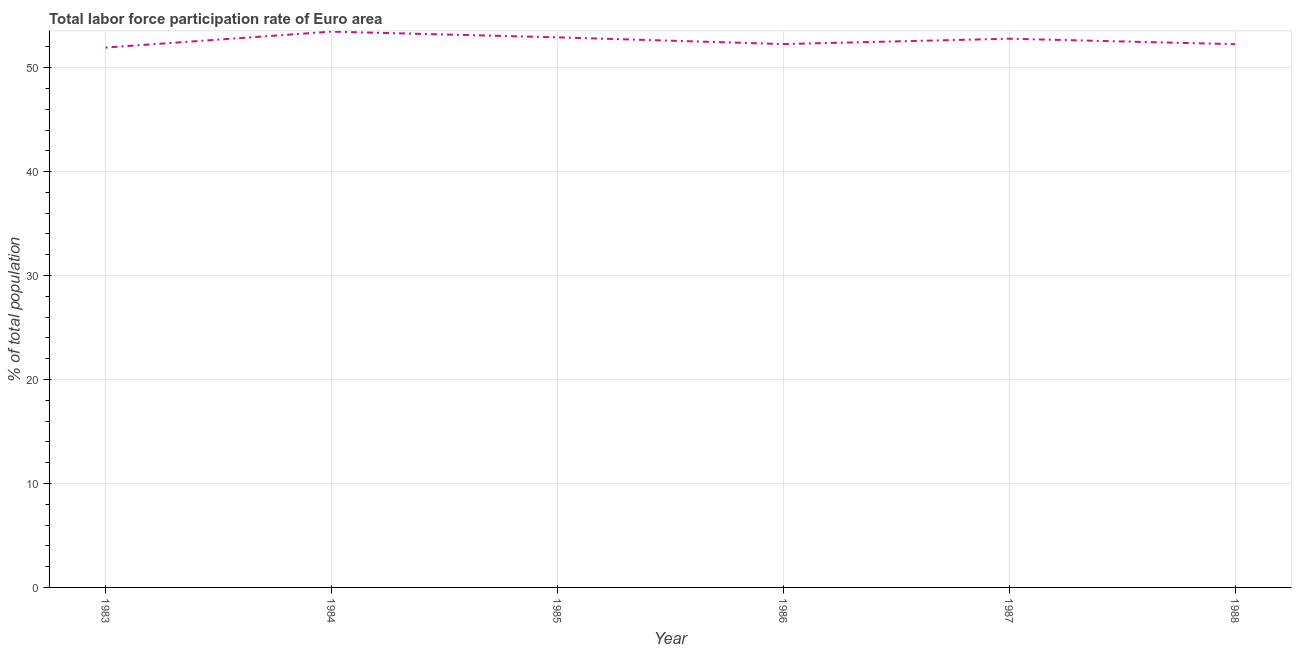What is the total labor force participation rate in 1983?
Make the answer very short. 51.93. Across all years, what is the maximum total labor force participation rate?
Provide a succinct answer. 53.47. Across all years, what is the minimum total labor force participation rate?
Your answer should be very brief. 51.93. In which year was the total labor force participation rate minimum?
Keep it short and to the point. 1983. What is the sum of the total labor force participation rate?
Make the answer very short. 315.63. What is the difference between the total labor force participation rate in 1983 and 1987?
Make the answer very short. -0.85. What is the average total labor force participation rate per year?
Give a very brief answer. 52.6. What is the median total labor force participation rate?
Ensure brevity in your answer.  52.53. Do a majority of the years between 1983 and 1985 (inclusive) have total labor force participation rate greater than 24 %?
Your answer should be compact. Yes. What is the ratio of the total labor force participation rate in 1983 to that in 1987?
Offer a very short reply. 0.98. Is the total labor force participation rate in 1984 less than that in 1987?
Keep it short and to the point. No. Is the difference between the total labor force participation rate in 1986 and 1987 greater than the difference between any two years?
Ensure brevity in your answer.  No. What is the difference between the highest and the second highest total labor force participation rate?
Give a very brief answer. 0.55. What is the difference between the highest and the lowest total labor force participation rate?
Ensure brevity in your answer.  1.53. In how many years, is the total labor force participation rate greater than the average total labor force participation rate taken over all years?
Make the answer very short. 3. How many lines are there?
Your answer should be very brief. 1. How many years are there in the graph?
Provide a short and direct response. 6. What is the difference between two consecutive major ticks on the Y-axis?
Offer a very short reply. 10. Are the values on the major ticks of Y-axis written in scientific E-notation?
Provide a short and direct response. No. Does the graph contain any zero values?
Your response must be concise. No. What is the title of the graph?
Make the answer very short. Total labor force participation rate of Euro area. What is the label or title of the Y-axis?
Provide a succinct answer. % of total population. What is the % of total population of 1983?
Make the answer very short. 51.93. What is the % of total population of 1984?
Make the answer very short. 53.47. What is the % of total population of 1985?
Offer a very short reply. 52.92. What is the % of total population in 1986?
Offer a terse response. 52.27. What is the % of total population of 1987?
Make the answer very short. 52.78. What is the % of total population of 1988?
Make the answer very short. 52.26. What is the difference between the % of total population in 1983 and 1984?
Your answer should be compact. -1.53. What is the difference between the % of total population in 1983 and 1985?
Keep it short and to the point. -0.99. What is the difference between the % of total population in 1983 and 1986?
Your answer should be compact. -0.34. What is the difference between the % of total population in 1983 and 1987?
Provide a succinct answer. -0.85. What is the difference between the % of total population in 1983 and 1988?
Provide a short and direct response. -0.33. What is the difference between the % of total population in 1984 and 1985?
Make the answer very short. 0.55. What is the difference between the % of total population in 1984 and 1986?
Ensure brevity in your answer.  1.2. What is the difference between the % of total population in 1984 and 1987?
Make the answer very short. 0.68. What is the difference between the % of total population in 1984 and 1988?
Your response must be concise. 1.21. What is the difference between the % of total population in 1985 and 1986?
Provide a succinct answer. 0.65. What is the difference between the % of total population in 1985 and 1987?
Offer a terse response. 0.13. What is the difference between the % of total population in 1985 and 1988?
Ensure brevity in your answer.  0.66. What is the difference between the % of total population in 1986 and 1987?
Keep it short and to the point. -0.51. What is the difference between the % of total population in 1986 and 1988?
Offer a very short reply. 0.01. What is the difference between the % of total population in 1987 and 1988?
Offer a terse response. 0.53. What is the ratio of the % of total population in 1983 to that in 1984?
Your response must be concise. 0.97. What is the ratio of the % of total population in 1984 to that in 1986?
Offer a terse response. 1.02. What is the ratio of the % of total population in 1985 to that in 1987?
Offer a very short reply. 1. What is the ratio of the % of total population in 1986 to that in 1987?
Provide a succinct answer. 0.99. 